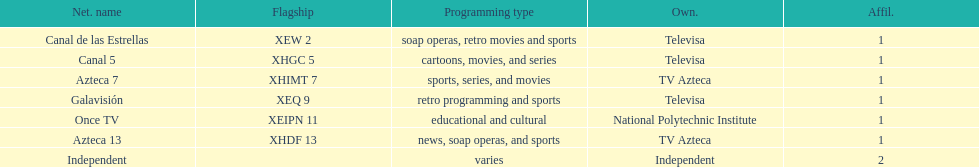Who is the owner of both azteca 7 and azteca 13? TV Azteca. Can you parse all the data within this table? {'header': ['Net. name', 'Flagship', 'Programming type', 'Own.', 'Affil.'], 'rows': [['Canal de las Estrellas', 'XEW 2', 'soap operas, retro movies and sports', 'Televisa', '1'], ['Canal 5', 'XHGC 5', 'cartoons, movies, and series', 'Televisa', '1'], ['Azteca 7', 'XHIMT 7', 'sports, series, and movies', 'TV Azteca', '1'], ['Galavisión', 'XEQ 9', 'retro programming and sports', 'Televisa', '1'], ['Once TV', 'XEIPN 11', 'educational and cultural', 'National Polytechnic Institute', '1'], ['Azteca 13', 'XHDF 13', 'news, soap operas, and sports', 'TV Azteca', '1'], ['Independent', '', 'varies', 'Independent', '2']]} 